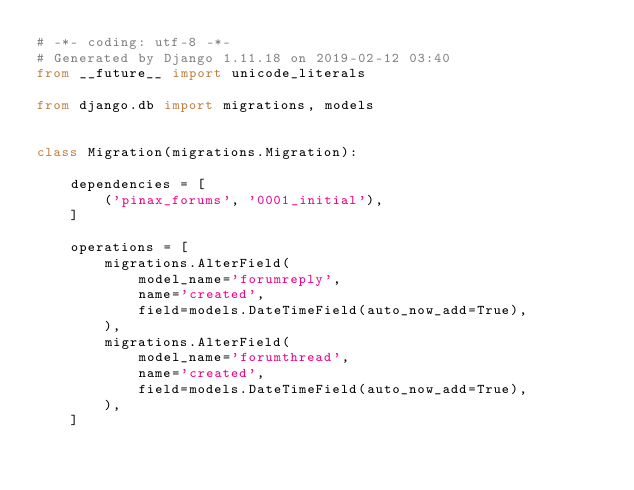<code> <loc_0><loc_0><loc_500><loc_500><_Python_># -*- coding: utf-8 -*-
# Generated by Django 1.11.18 on 2019-02-12 03:40
from __future__ import unicode_literals

from django.db import migrations, models


class Migration(migrations.Migration):

    dependencies = [
        ('pinax_forums', '0001_initial'),
    ]

    operations = [
        migrations.AlterField(
            model_name='forumreply',
            name='created',
            field=models.DateTimeField(auto_now_add=True),
        ),
        migrations.AlterField(
            model_name='forumthread',
            name='created',
            field=models.DateTimeField(auto_now_add=True),
        ),
    ]
</code> 